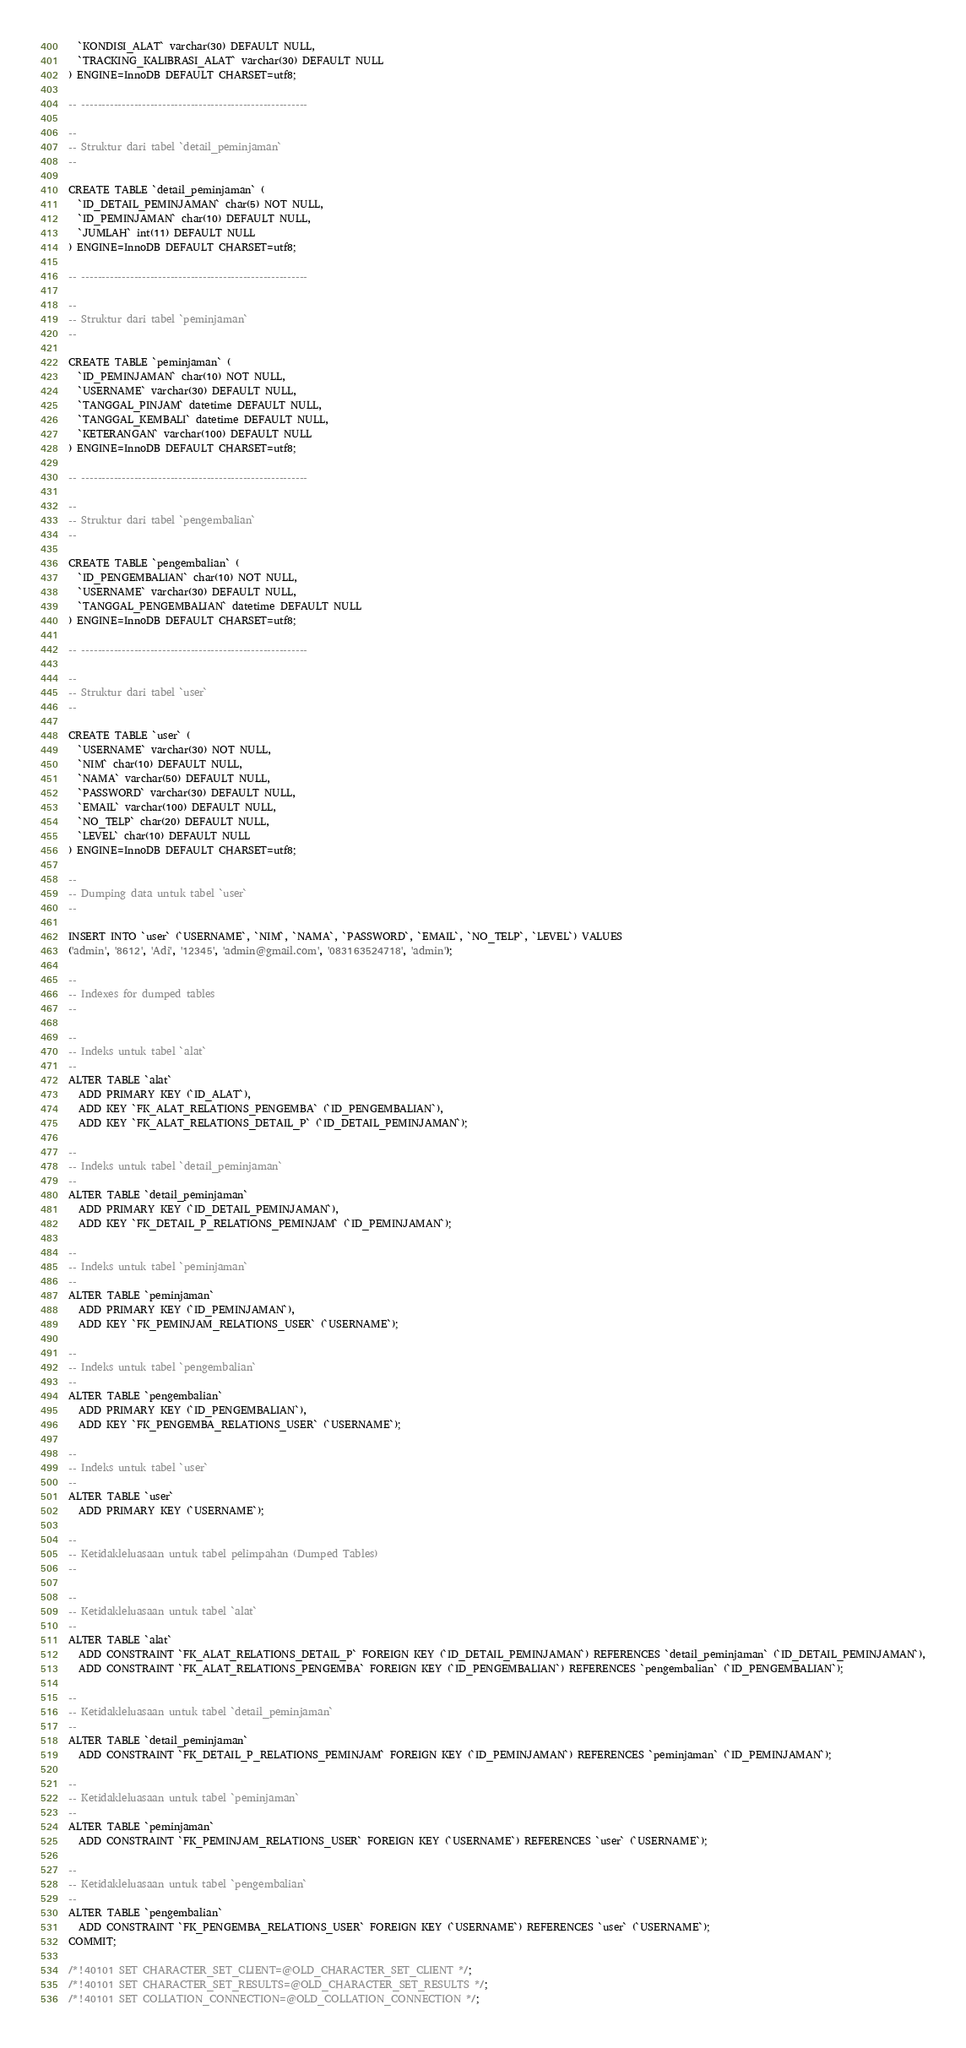<code> <loc_0><loc_0><loc_500><loc_500><_SQL_>  `KONDISI_ALAT` varchar(30) DEFAULT NULL,
  `TRACKING_KALIBRASI_ALAT` varchar(30) DEFAULT NULL
) ENGINE=InnoDB DEFAULT CHARSET=utf8;

-- --------------------------------------------------------

--
-- Struktur dari tabel `detail_peminjaman`
--

CREATE TABLE `detail_peminjaman` (
  `ID_DETAIL_PEMINJAMAN` char(5) NOT NULL,
  `ID_PEMINJAMAN` char(10) DEFAULT NULL,
  `JUMLAH` int(11) DEFAULT NULL
) ENGINE=InnoDB DEFAULT CHARSET=utf8;

-- --------------------------------------------------------

--
-- Struktur dari tabel `peminjaman`
--

CREATE TABLE `peminjaman` (
  `ID_PEMINJAMAN` char(10) NOT NULL,
  `USERNAME` varchar(30) DEFAULT NULL,
  `TANGGAL_PINJAM` datetime DEFAULT NULL,
  `TANGGAL_KEMBALI` datetime DEFAULT NULL,
  `KETERANGAN` varchar(100) DEFAULT NULL
) ENGINE=InnoDB DEFAULT CHARSET=utf8;

-- --------------------------------------------------------

--
-- Struktur dari tabel `pengembalian`
--

CREATE TABLE `pengembalian` (
  `ID_PENGEMBALIAN` char(10) NOT NULL,
  `USERNAME` varchar(30) DEFAULT NULL,
  `TANGGAL_PENGEMBALIAN` datetime DEFAULT NULL
) ENGINE=InnoDB DEFAULT CHARSET=utf8;

-- --------------------------------------------------------

--
-- Struktur dari tabel `user`
--

CREATE TABLE `user` (
  `USERNAME` varchar(30) NOT NULL,
  `NIM` char(10) DEFAULT NULL,
  `NAMA` varchar(50) DEFAULT NULL,
  `PASSWORD` varchar(30) DEFAULT NULL,
  `EMAIL` varchar(100) DEFAULT NULL,
  `NO_TELP` char(20) DEFAULT NULL,
  `LEVEL` char(10) DEFAULT NULL
) ENGINE=InnoDB DEFAULT CHARSET=utf8;

--
-- Dumping data untuk tabel `user`
--

INSERT INTO `user` (`USERNAME`, `NIM`, `NAMA`, `PASSWORD`, `EMAIL`, `NO_TELP`, `LEVEL`) VALUES
('admin', '8612', 'Adi', '12345', 'admin@gmail.com', '083163524718', 'admin');

--
-- Indexes for dumped tables
--

--
-- Indeks untuk tabel `alat`
--
ALTER TABLE `alat`
  ADD PRIMARY KEY (`ID_ALAT`),
  ADD KEY `FK_ALAT_RELATIONS_PENGEMBA` (`ID_PENGEMBALIAN`),
  ADD KEY `FK_ALAT_RELATIONS_DETAIL_P` (`ID_DETAIL_PEMINJAMAN`);

--
-- Indeks untuk tabel `detail_peminjaman`
--
ALTER TABLE `detail_peminjaman`
  ADD PRIMARY KEY (`ID_DETAIL_PEMINJAMAN`),
  ADD KEY `FK_DETAIL_P_RELATIONS_PEMINJAM` (`ID_PEMINJAMAN`);

--
-- Indeks untuk tabel `peminjaman`
--
ALTER TABLE `peminjaman`
  ADD PRIMARY KEY (`ID_PEMINJAMAN`),
  ADD KEY `FK_PEMINJAM_RELATIONS_USER` (`USERNAME`);

--
-- Indeks untuk tabel `pengembalian`
--
ALTER TABLE `pengembalian`
  ADD PRIMARY KEY (`ID_PENGEMBALIAN`),
  ADD KEY `FK_PENGEMBA_RELATIONS_USER` (`USERNAME`);

--
-- Indeks untuk tabel `user`
--
ALTER TABLE `user`
  ADD PRIMARY KEY (`USERNAME`);

--
-- Ketidakleluasaan untuk tabel pelimpahan (Dumped Tables)
--

--
-- Ketidakleluasaan untuk tabel `alat`
--
ALTER TABLE `alat`
  ADD CONSTRAINT `FK_ALAT_RELATIONS_DETAIL_P` FOREIGN KEY (`ID_DETAIL_PEMINJAMAN`) REFERENCES `detail_peminjaman` (`ID_DETAIL_PEMINJAMAN`),
  ADD CONSTRAINT `FK_ALAT_RELATIONS_PENGEMBA` FOREIGN KEY (`ID_PENGEMBALIAN`) REFERENCES `pengembalian` (`ID_PENGEMBALIAN`);

--
-- Ketidakleluasaan untuk tabel `detail_peminjaman`
--
ALTER TABLE `detail_peminjaman`
  ADD CONSTRAINT `FK_DETAIL_P_RELATIONS_PEMINJAM` FOREIGN KEY (`ID_PEMINJAMAN`) REFERENCES `peminjaman` (`ID_PEMINJAMAN`);

--
-- Ketidakleluasaan untuk tabel `peminjaman`
--
ALTER TABLE `peminjaman`
  ADD CONSTRAINT `FK_PEMINJAM_RELATIONS_USER` FOREIGN KEY (`USERNAME`) REFERENCES `user` (`USERNAME`);

--
-- Ketidakleluasaan untuk tabel `pengembalian`
--
ALTER TABLE `pengembalian`
  ADD CONSTRAINT `FK_PENGEMBA_RELATIONS_USER` FOREIGN KEY (`USERNAME`) REFERENCES `user` (`USERNAME`);
COMMIT;

/*!40101 SET CHARACTER_SET_CLIENT=@OLD_CHARACTER_SET_CLIENT */;
/*!40101 SET CHARACTER_SET_RESULTS=@OLD_CHARACTER_SET_RESULTS */;
/*!40101 SET COLLATION_CONNECTION=@OLD_COLLATION_CONNECTION */;
</code> 